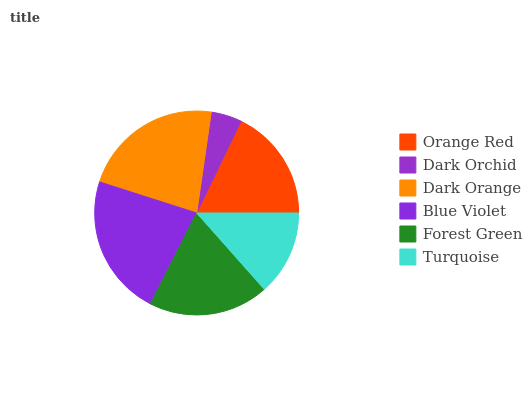Is Dark Orchid the minimum?
Answer yes or no. Yes. Is Blue Violet the maximum?
Answer yes or no. Yes. Is Dark Orange the minimum?
Answer yes or no. No. Is Dark Orange the maximum?
Answer yes or no. No. Is Dark Orange greater than Dark Orchid?
Answer yes or no. Yes. Is Dark Orchid less than Dark Orange?
Answer yes or no. Yes. Is Dark Orchid greater than Dark Orange?
Answer yes or no. No. Is Dark Orange less than Dark Orchid?
Answer yes or no. No. Is Forest Green the high median?
Answer yes or no. Yes. Is Orange Red the low median?
Answer yes or no. Yes. Is Blue Violet the high median?
Answer yes or no. No. Is Forest Green the low median?
Answer yes or no. No. 